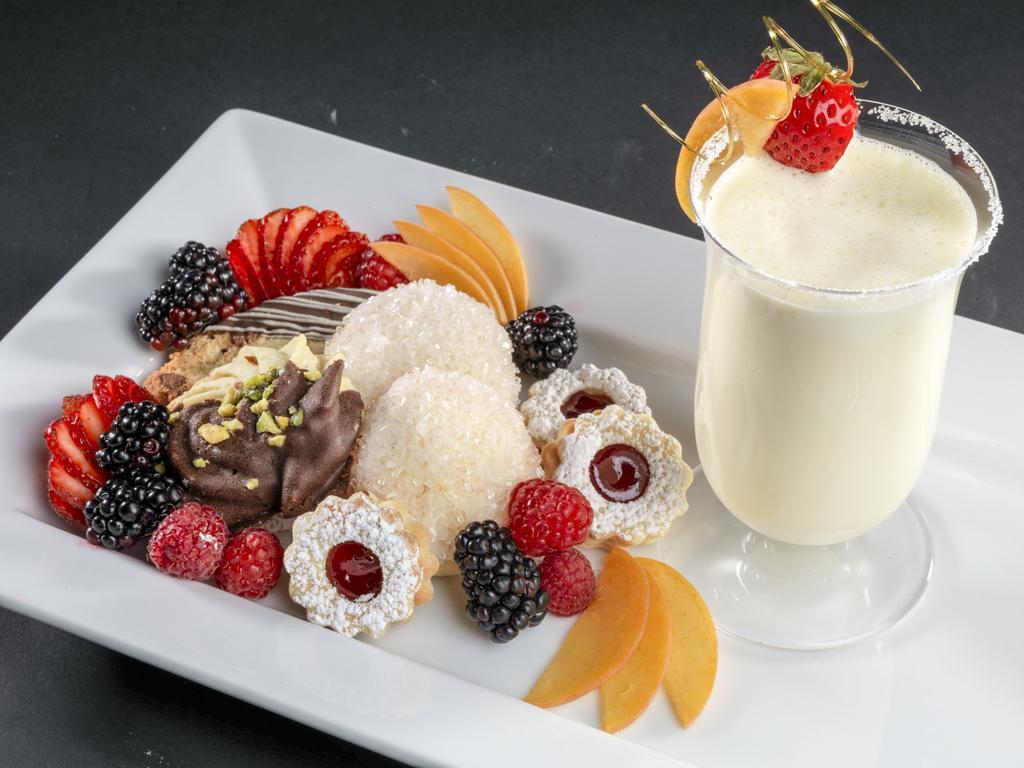Describe this image in one or two sentences. In this image there are food items and a glass of juice placed on a tray. 